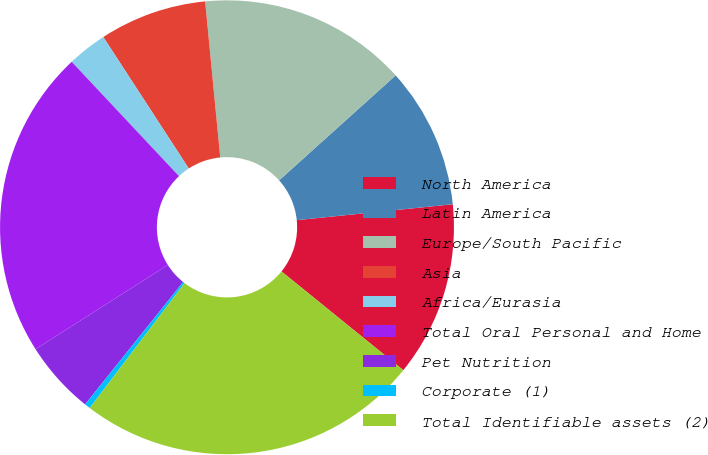<chart> <loc_0><loc_0><loc_500><loc_500><pie_chart><fcel>North America<fcel>Latin America<fcel>Europe/South Pacific<fcel>Asia<fcel>Africa/Eurasia<fcel>Total Oral Personal and Home<fcel>Pet Nutrition<fcel>Corporate (1)<fcel>Total Identifiable assets (2)<nl><fcel>12.46%<fcel>10.05%<fcel>14.87%<fcel>7.64%<fcel>2.82%<fcel>22.03%<fcel>5.23%<fcel>0.41%<fcel>24.5%<nl></chart> 